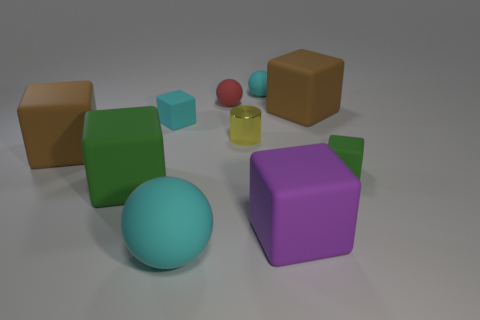Subtract all cyan rubber cubes. How many cubes are left? 5 Subtract all purple blocks. How many blocks are left? 5 Subtract all cyan blocks. Subtract all red cylinders. How many blocks are left? 5 Subtract all cylinders. How many objects are left? 9 Add 7 big gray metallic balls. How many big gray metallic balls exist? 7 Subtract 0 red cylinders. How many objects are left? 10 Subtract all small brown cylinders. Subtract all big cyan rubber spheres. How many objects are left? 9 Add 3 purple cubes. How many purple cubes are left? 4 